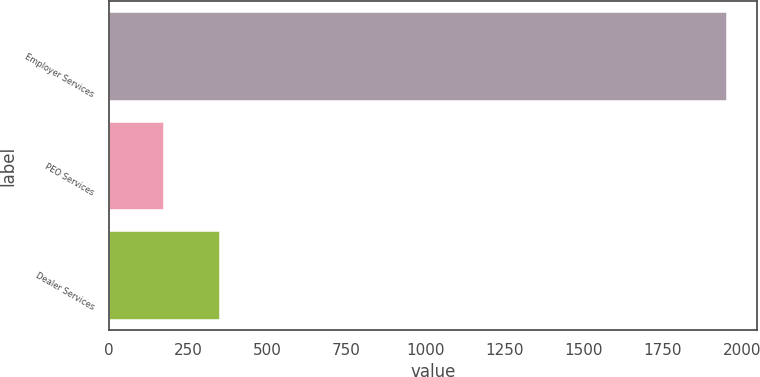<chart> <loc_0><loc_0><loc_500><loc_500><bar_chart><fcel>Employer Services<fcel>PEO Services<fcel>Dealer Services<nl><fcel>1949.2<fcel>170.6<fcel>348.46<nl></chart> 